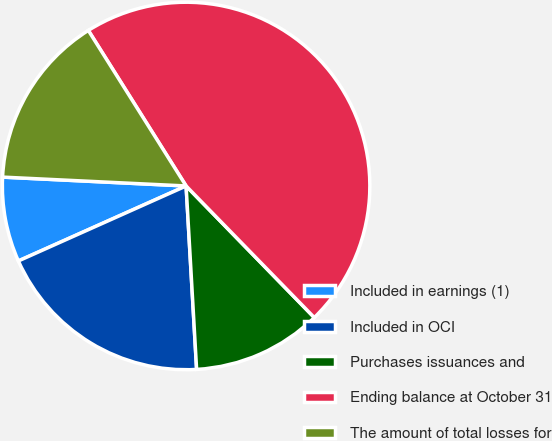Convert chart. <chart><loc_0><loc_0><loc_500><loc_500><pie_chart><fcel>Included in earnings (1)<fcel>Included in OCI<fcel>Purchases issuances and<fcel>Ending balance at October 31<fcel>The amount of total losses for<nl><fcel>7.46%<fcel>19.22%<fcel>11.38%<fcel>46.64%<fcel>15.3%<nl></chart> 